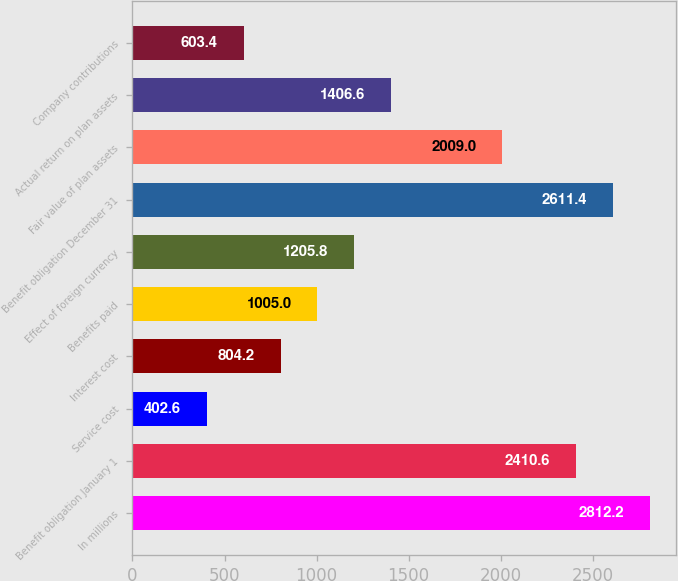Convert chart to OTSL. <chart><loc_0><loc_0><loc_500><loc_500><bar_chart><fcel>In millions<fcel>Benefit obligation January 1<fcel>Service cost<fcel>Interest cost<fcel>Benefits paid<fcel>Effect of foreign currency<fcel>Benefit obligation December 31<fcel>Fair value of plan assets<fcel>Actual return on plan assets<fcel>Company contributions<nl><fcel>2812.2<fcel>2410.6<fcel>402.6<fcel>804.2<fcel>1005<fcel>1205.8<fcel>2611.4<fcel>2009<fcel>1406.6<fcel>603.4<nl></chart> 